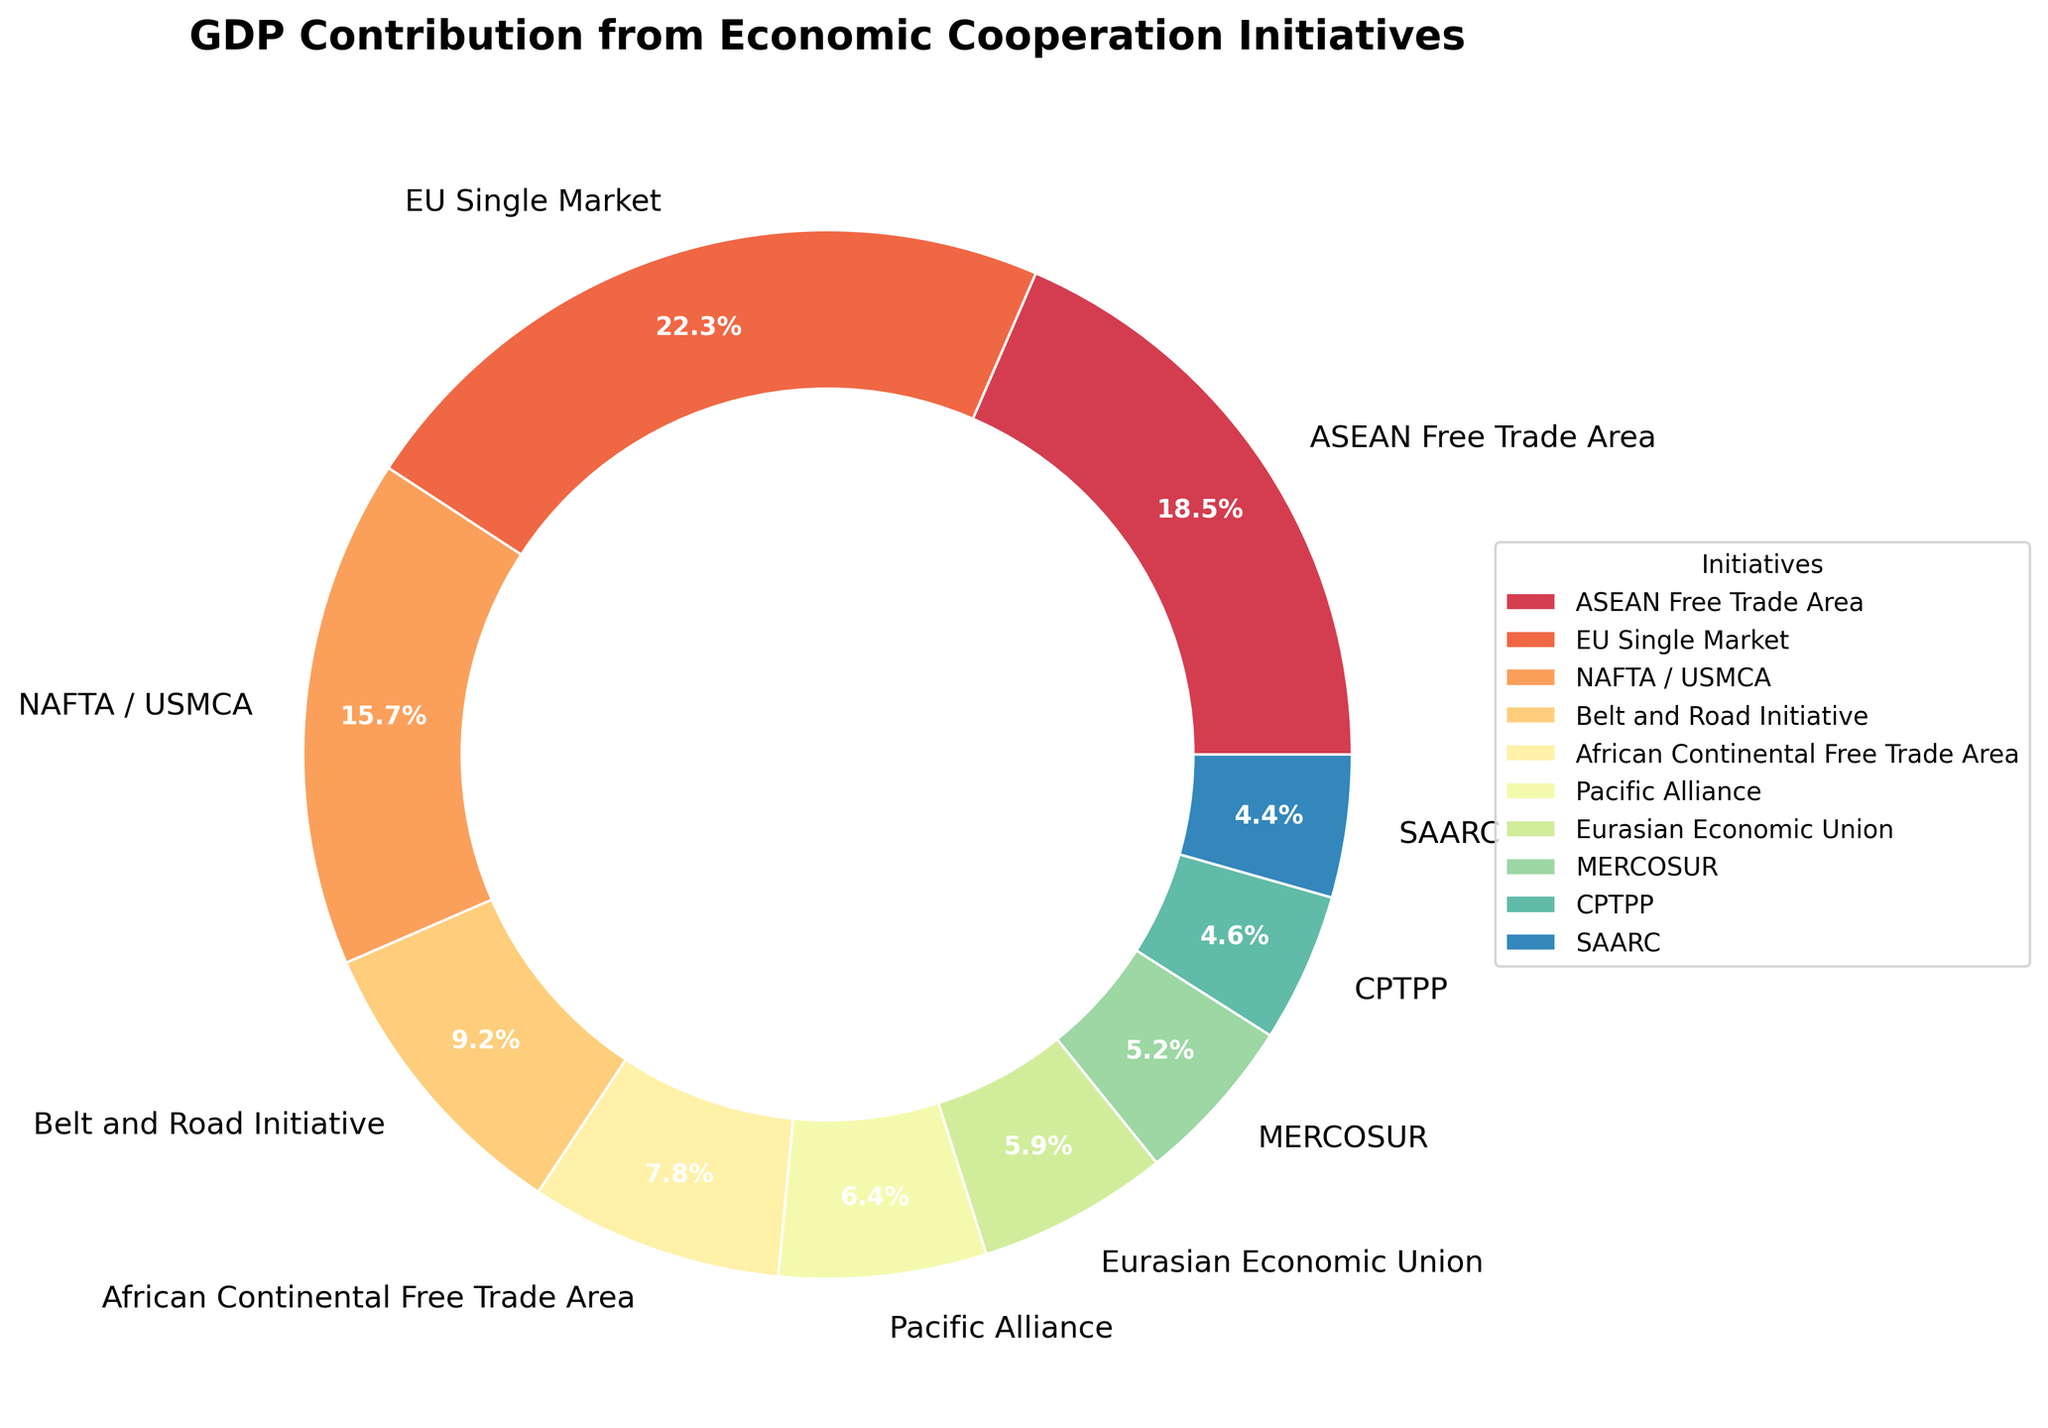What is the total GDP contribution from the EU Single Market and NAFTA / USMCA? To find the total GDP contribution from the EU Single Market and NAFTA / USMCA, we need to sum their percentages: EU Single Market (22.3%) + NAFTA / USMCA (15.7%) = 38.0%.
Answer: 38.0% Which initiative contributes more to GDP: ASEAN Free Trade Area or Belt and Road Initiative? We compare the percentages of the GDP contributions: ASEAN Free Trade Area (18.5%) is higher than Belt and Road Initiative (9.2%).
Answer: ASEAN Free Trade Area What is the average GDP contribution of African Continental Free Trade Area, Pacific Alliance, and Eurasian Economic Union? First, sum the percentages: 7.8% (African Continental Free Trade Area) + 6.4% (Pacific Alliance) + 5.9% (Eurasian Economic Union) = 20.1%. Then, divide by the number of initiatives: 20.1 / 3 = 6.7%.
Answer: 6.7% How much more does the EU Single Market contribute to GDP compared to the CPTPP? To determine the difference, subtract CPTPP's percentage from EU Single Market's percentage: 22.3% - 4.6% = 17.7%.
Answer: 17.7% Which initiative has the smallest GDP contribution from the list? Comparing all percentages, the smallest GDP contribution is from SAARC at 4.4%.
Answer: SAARC Is the GDP contribution from the ASEAN Free Trade Area greater than the combined contribution of Pacific Alliance and MERCOSUR? Sum the contributions of Pacific Alliance (6.4%) and MERCOSUR (5.2%): 6.4% + 5.2% = 11.6%. Compare it with ASEAN Free Trade Area (18.5%), which is greater.
Answer: Yes What is the combined GDP contribution of initiatives contributing more than 10%? The initiatives with more than 10% are ASEAN Free Trade Area (18.5%), EU Single Market (22.3%), and NAFTA / USMCA (15.7%). Sum these contributions: 18.5% + 22.3% + 15.7% = 56.5%.
Answer: 56.5% Which initiative has a larger GDP contribution: Eurasian Economic Union or MERCOSUR? Comparing the percentages, Eurasian Economic Union (5.9%) is larger than MERCOSUR (5.2%).
Answer: Eurasian Economic Union Among the listed initiatives, what is the total GDP contribution percentage from the initiatives located in Asia? The initiatives based in Asia are ASEAN Free Trade Area (18.5%), Belt and Road Initiative (9.2%), and SAARC (4.4%). Sum these contributions: 18.5% + 9.2% + 4.4% = 32.1%.
Answer: 32.1% 